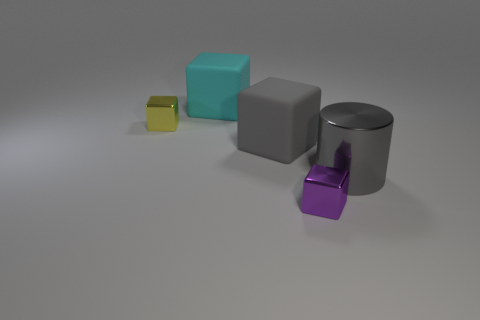The gray matte object that is the same size as the gray cylinder is what shape?
Give a very brief answer. Cube. Are the small yellow thing and the big cylinder made of the same material?
Keep it short and to the point. Yes. What number of matte things are brown balls or tiny yellow blocks?
Provide a succinct answer. 0. There is a large matte object that is in front of the cyan matte block; is its color the same as the big metal thing?
Your answer should be very brief. Yes. What shape is the thing behind the yellow metal object that is in front of the big cyan rubber thing?
Provide a succinct answer. Cube. How many things are matte cubes left of the big metal object or tiny purple shiny cubes that are in front of the gray block?
Keep it short and to the point. 3. What is the shape of the tiny thing that is the same material as the tiny yellow cube?
Keep it short and to the point. Cube. What material is the small yellow object that is the same shape as the large gray rubber object?
Keep it short and to the point. Metal. How many other objects are there of the same size as the shiny cylinder?
Give a very brief answer. 2. What is the material of the gray cylinder?
Ensure brevity in your answer.  Metal. 